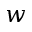<formula> <loc_0><loc_0><loc_500><loc_500>w</formula> 